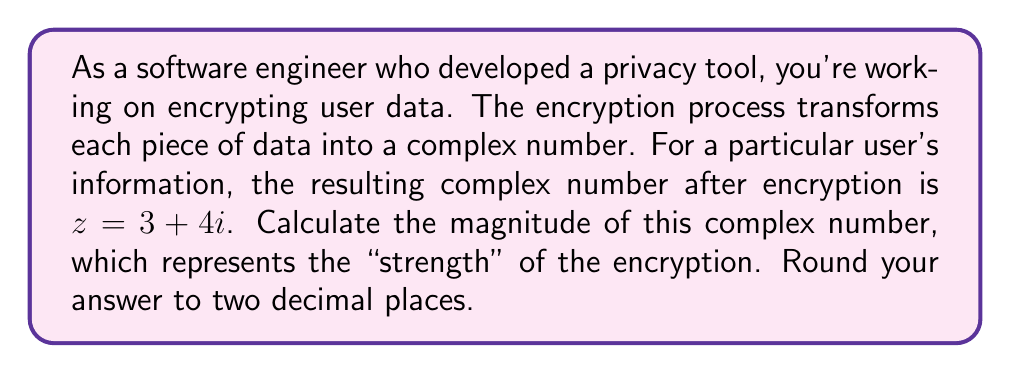Show me your answer to this math problem. To calculate the magnitude of a complex number, we use the formula:

$$ |z| = \sqrt{a^2 + b^2} $$

Where $z = a + bi$ is the complex number, $a$ is the real part, and $b$ is the imaginary part.

For the given complex number $z = 3 + 4i$:
$a = 3$ (real part)
$b = 4$ (imaginary part)

Substituting these values into the formula:

$$ |z| = \sqrt{3^2 + 4^2} $$

$$ |z| = \sqrt{9 + 16} $$

$$ |z| = \sqrt{25} $$

$$ |z| = 5 $$

The magnitude of the complex number is exactly 5, so no rounding is necessary in this case.

In the context of encrypted data, a larger magnitude could indicate a stronger encryption, as it represents a greater distance from the origin in the complex plane. However, the actual strength of encryption depends on the specific algorithm and key used, not just the magnitude of the resulting complex number.
Answer: $5.00$ 